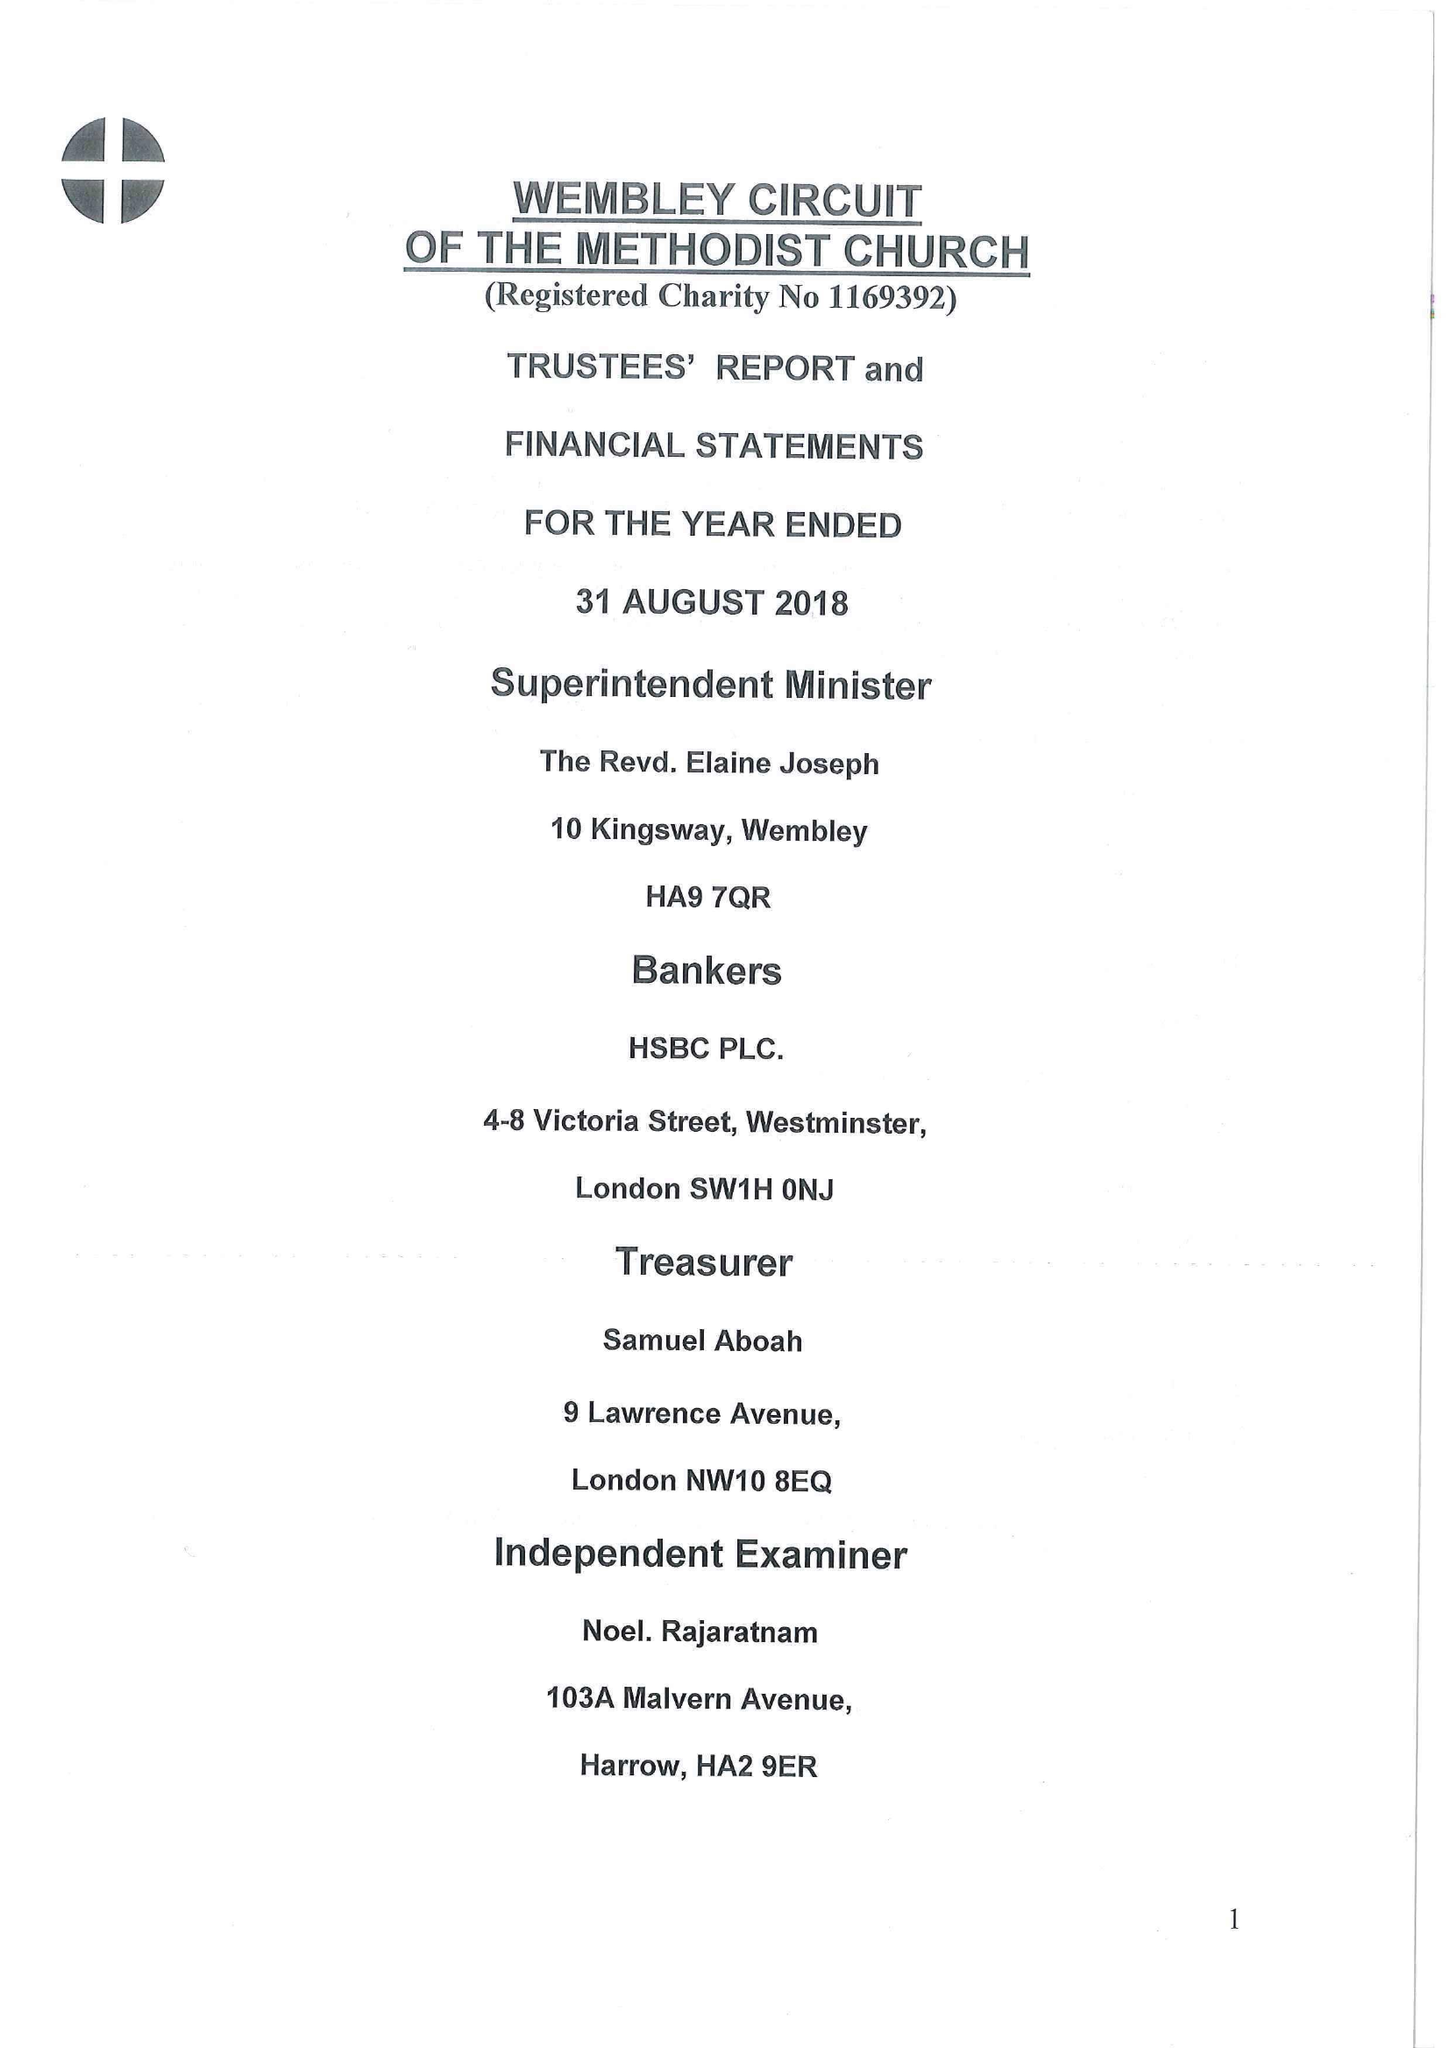What is the value for the report_date?
Answer the question using a single word or phrase. 2018-08-31 